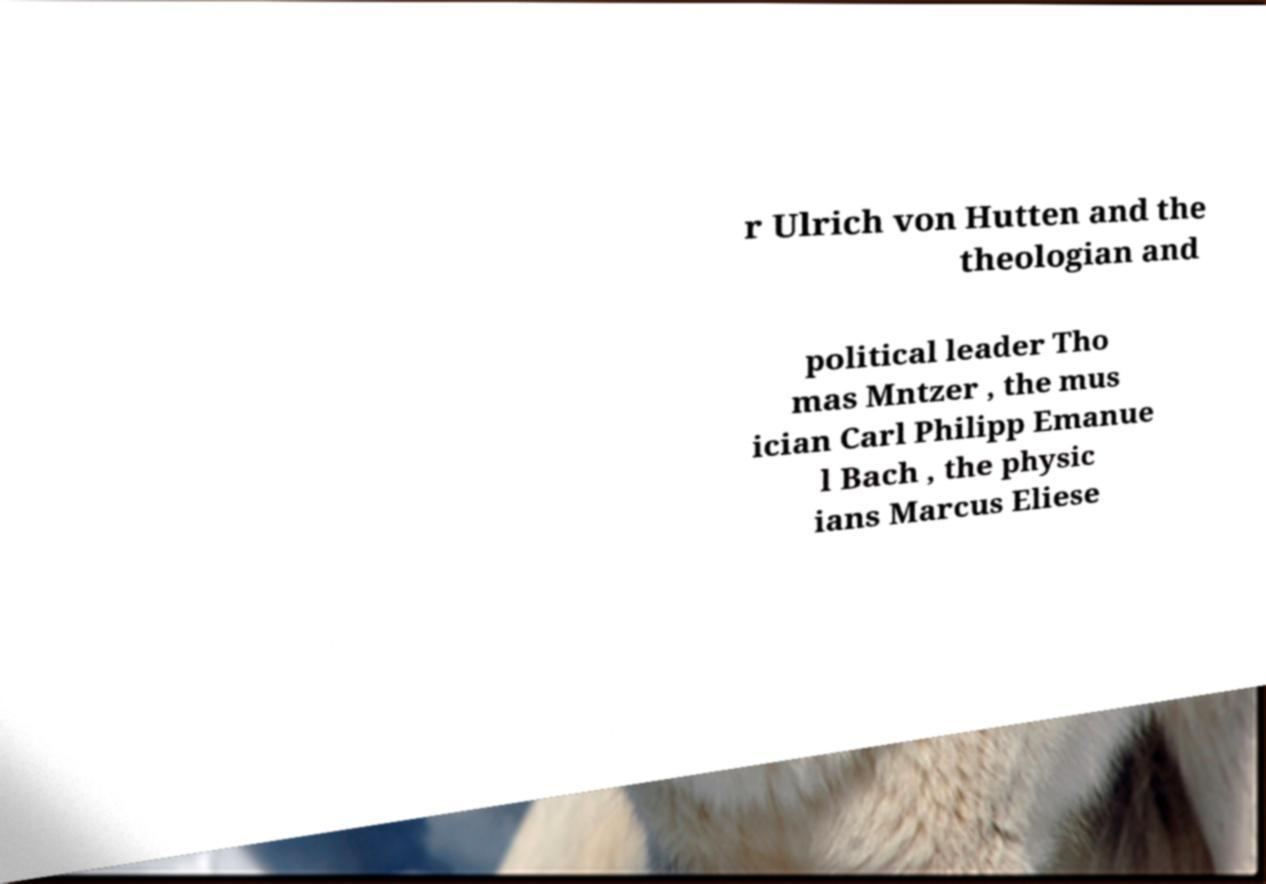I need the written content from this picture converted into text. Can you do that? r Ulrich von Hutten and the theologian and political leader Tho mas Mntzer , the mus ician Carl Philipp Emanue l Bach , the physic ians Marcus Eliese 